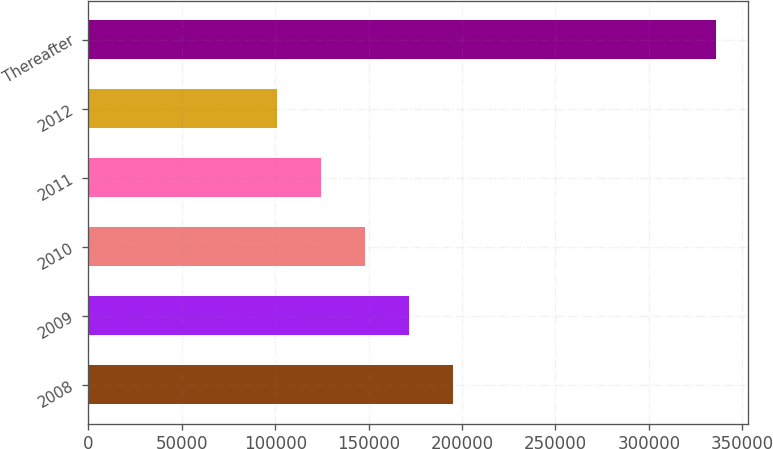<chart> <loc_0><loc_0><loc_500><loc_500><bar_chart><fcel>2008<fcel>2009<fcel>2010<fcel>2011<fcel>2012<fcel>Thereafter<nl><fcel>195073<fcel>171564<fcel>148054<fcel>124545<fcel>101035<fcel>336131<nl></chart> 